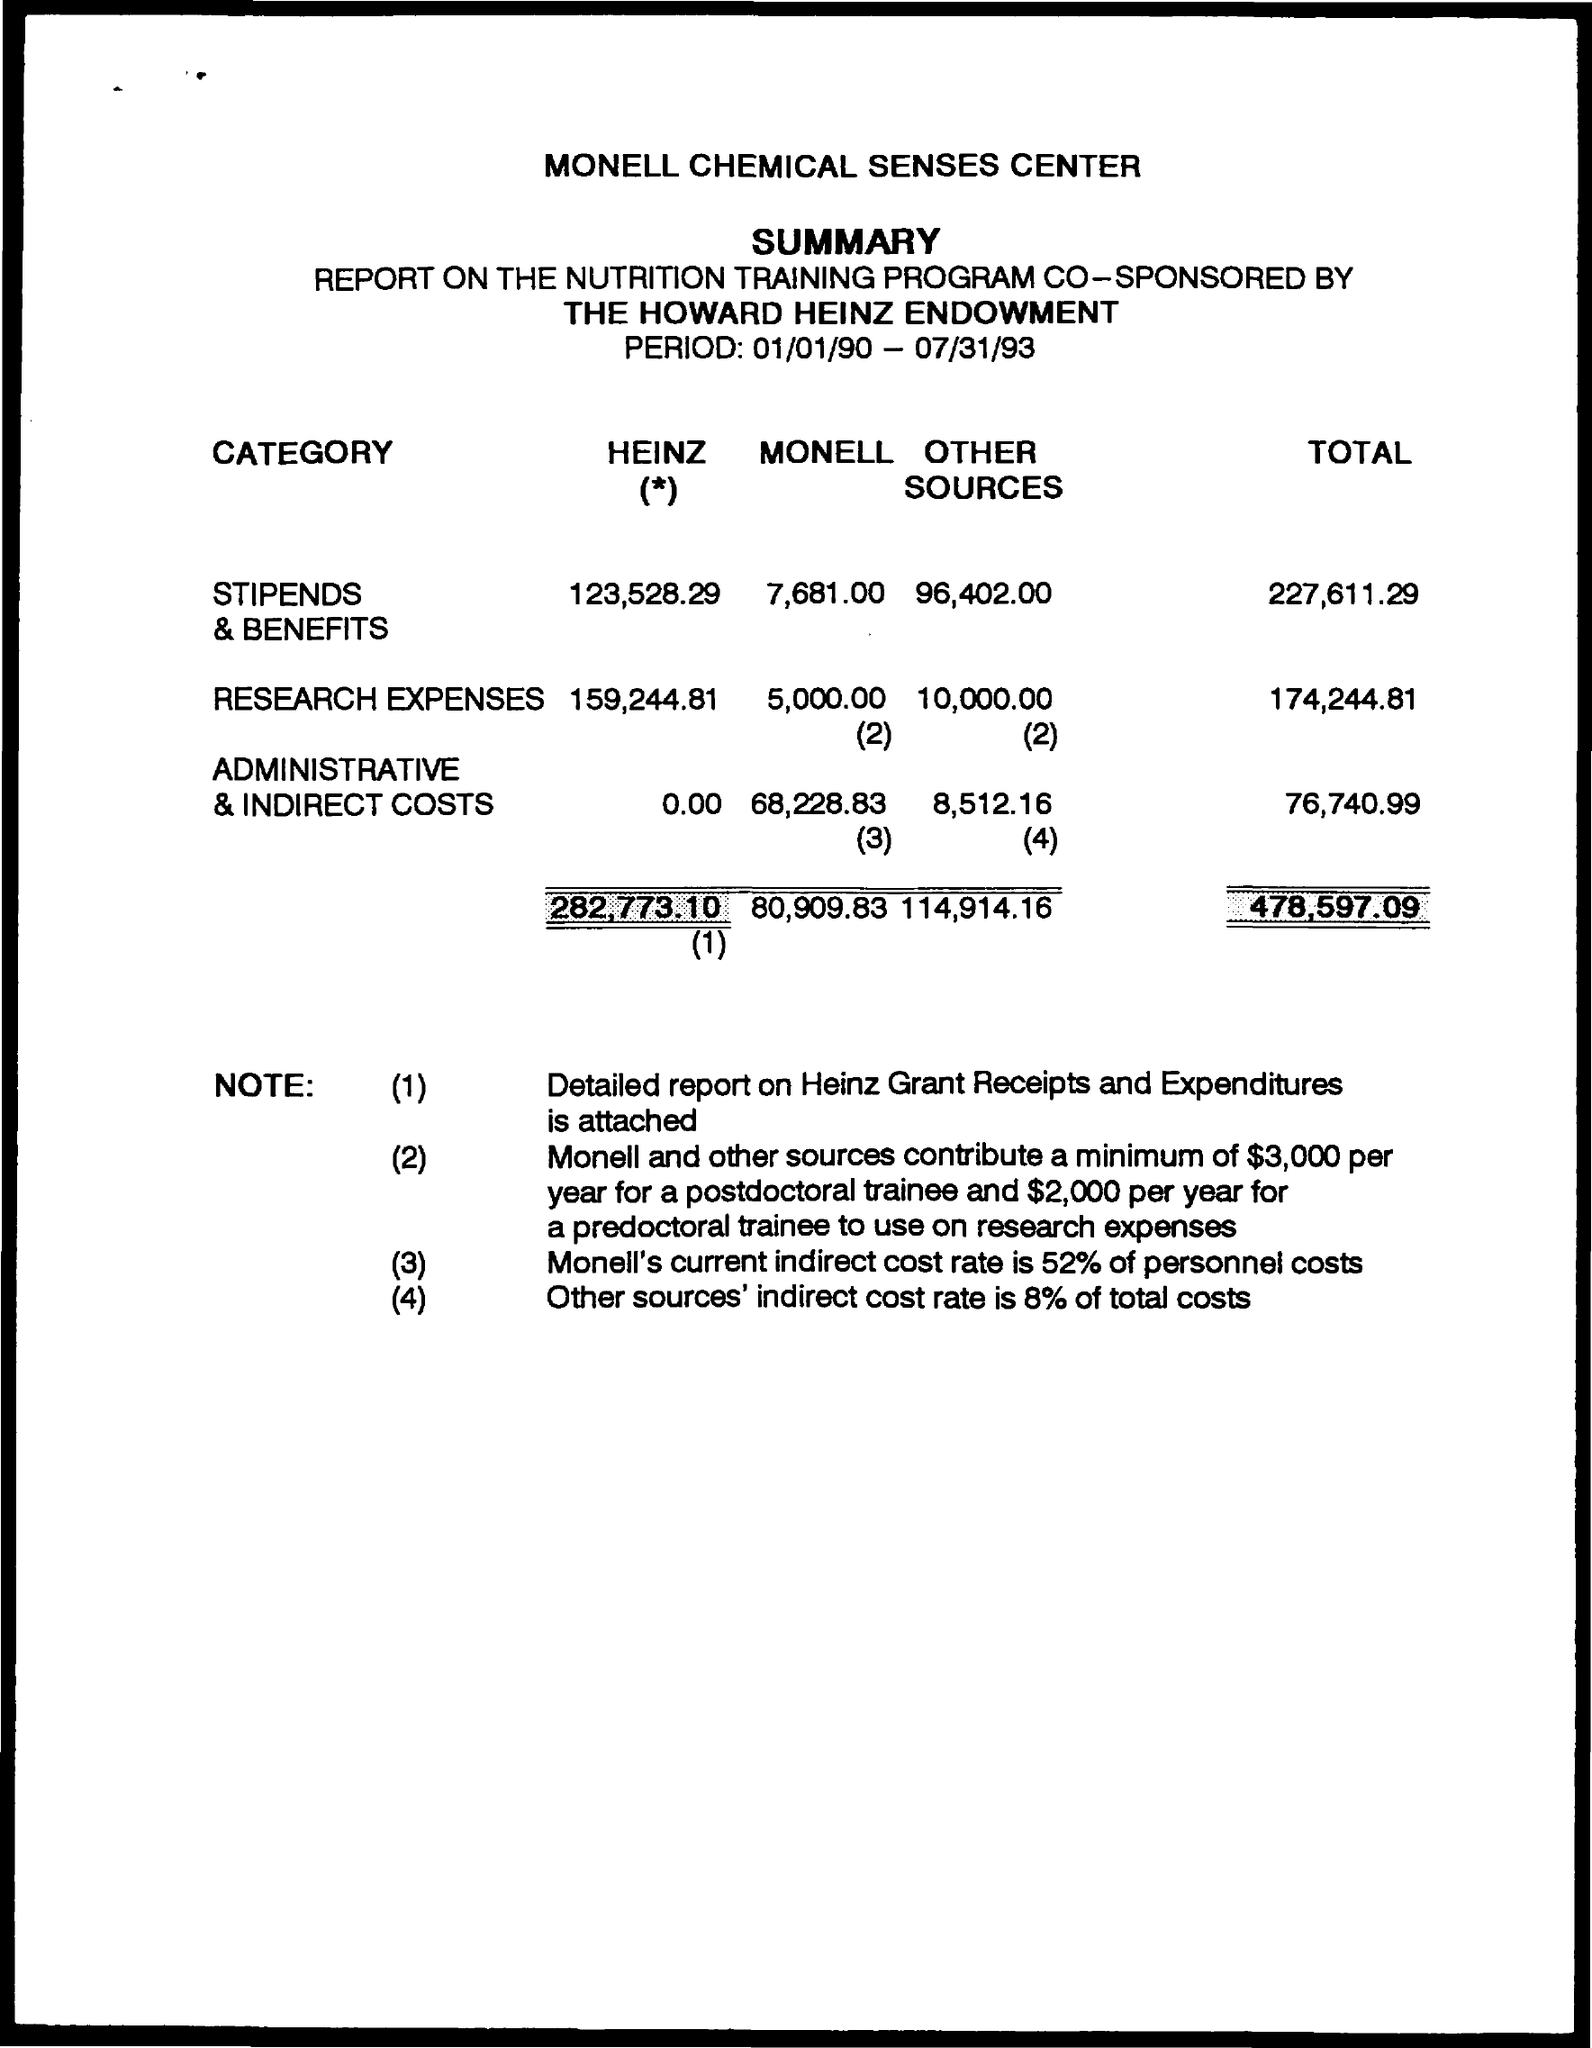What is the total cost?
Your answer should be very brief. 478,597.09. What is the period duration?
Provide a short and direct response. 01/01/90 - 07/31/93. What percentage of total cost is taken as indirect cost rate for other sources?
Offer a very short reply. 8%. How much is the total cost of "Heinz" ?
Ensure brevity in your answer.  282,773.10. Which centers information is given in the document?
Provide a short and direct response. Monell Chemical Senses center. Detailed report on what, is attached along with this document?
Provide a short and direct response. Heinz Grant Receipts and expenditures. What is the total cost of "Stipends and Benefits" ?
Offer a very short reply. 227,611.29. 